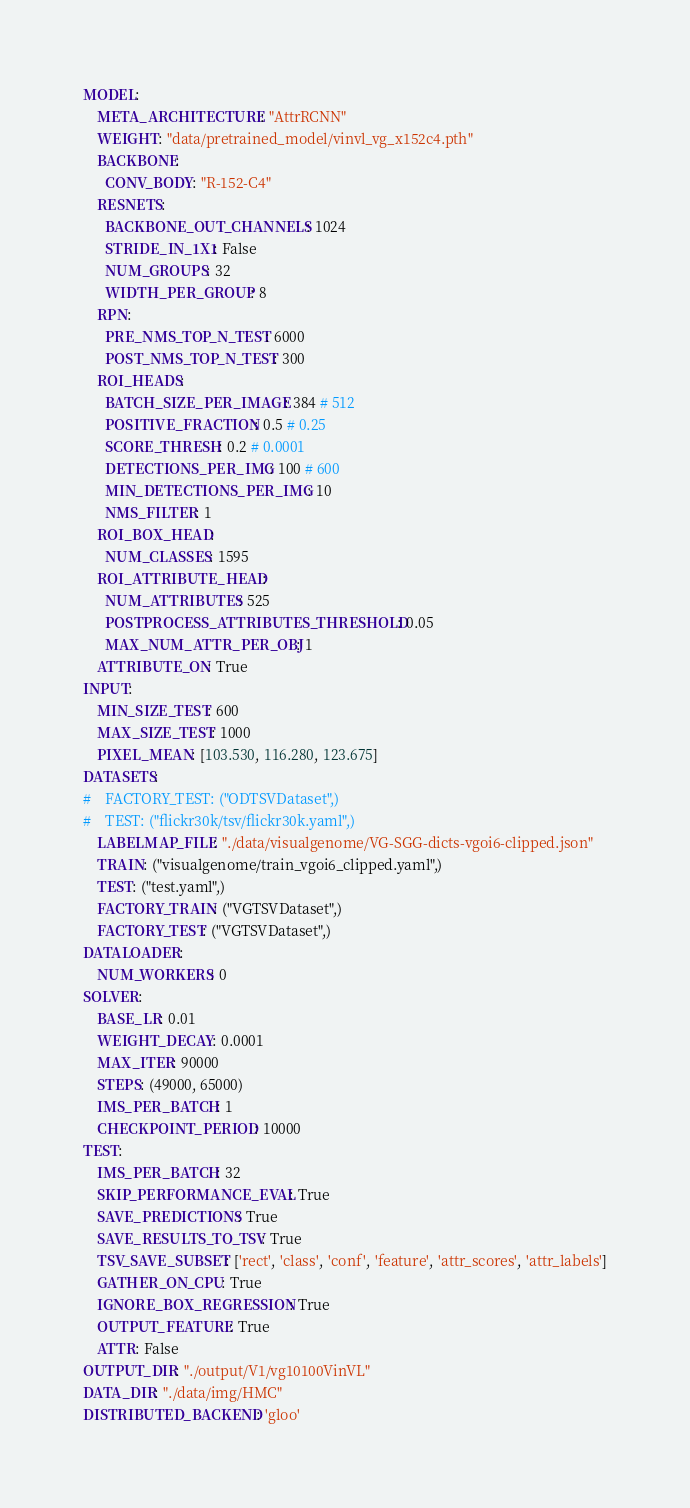Convert code to text. <code><loc_0><loc_0><loc_500><loc_500><_YAML_>MODEL:
    META_ARCHITECTURE: "AttrRCNN"
    WEIGHT: "data/pretrained_model/vinvl_vg_x152c4.pth"
    BACKBONE:
      CONV_BODY: "R-152-C4"
    RESNETS:
      BACKBONE_OUT_CHANNELS: 1024
      STRIDE_IN_1X1: False
      NUM_GROUPS: 32
      WIDTH_PER_GROUP: 8
    RPN:
      PRE_NMS_TOP_N_TEST: 6000
      POST_NMS_TOP_N_TEST: 300
    ROI_HEADS:
      BATCH_SIZE_PER_IMAGE: 384 # 512
      POSITIVE_FRACTION: 0.5 # 0.25
      SCORE_THRESH: 0.2 # 0.0001
      DETECTIONS_PER_IMG: 100 # 600
      MIN_DETECTIONS_PER_IMG: 10
      NMS_FILTER: 1
    ROI_BOX_HEAD:
      NUM_CLASSES: 1595
    ROI_ATTRIBUTE_HEAD:
      NUM_ATTRIBUTES: 525
      POSTPROCESS_ATTRIBUTES_THRESHOLD: 0.05
      MAX_NUM_ATTR_PER_OBJ: 1
    ATTRIBUTE_ON: True
INPUT:
    MIN_SIZE_TEST: 600
    MAX_SIZE_TEST: 1000
    PIXEL_MEAN: [103.530, 116.280, 123.675]
DATASETS:
#    FACTORY_TEST: ("ODTSVDataset",)
#    TEST: ("flickr30k/tsv/flickr30k.yaml",)
    LABELMAP_FILE: "./data/visualgenome/VG-SGG-dicts-vgoi6-clipped.json"
    TRAIN: ("visualgenome/train_vgoi6_clipped.yaml",)
    TEST: ("test.yaml",)
    FACTORY_TRAIN: ("VGTSVDataset",)
    FACTORY_TEST: ("VGTSVDataset",)
DATALOADER:
    NUM_WORKERS: 0
SOLVER:
    BASE_LR: 0.01
    WEIGHT_DECAY: 0.0001
    MAX_ITER: 90000
    STEPS: (49000, 65000)
    IMS_PER_BATCH: 1
    CHECKPOINT_PERIOD: 10000
TEST:
    IMS_PER_BATCH: 32
    SKIP_PERFORMANCE_EVAL: True
    SAVE_PREDICTIONS: True
    SAVE_RESULTS_TO_TSV: True
    TSV_SAVE_SUBSET: ['rect', 'class', 'conf', 'feature', 'attr_scores', 'attr_labels']
    GATHER_ON_CPU: True
    IGNORE_BOX_REGRESSION: True
    OUTPUT_FEATURE: True
    ATTR: False
OUTPUT_DIR: "./output/V1/vg10100VinVL"
DATA_DIR: "./data/img/HMC"
DISTRIBUTED_BACKEND: 'gloo'</code> 